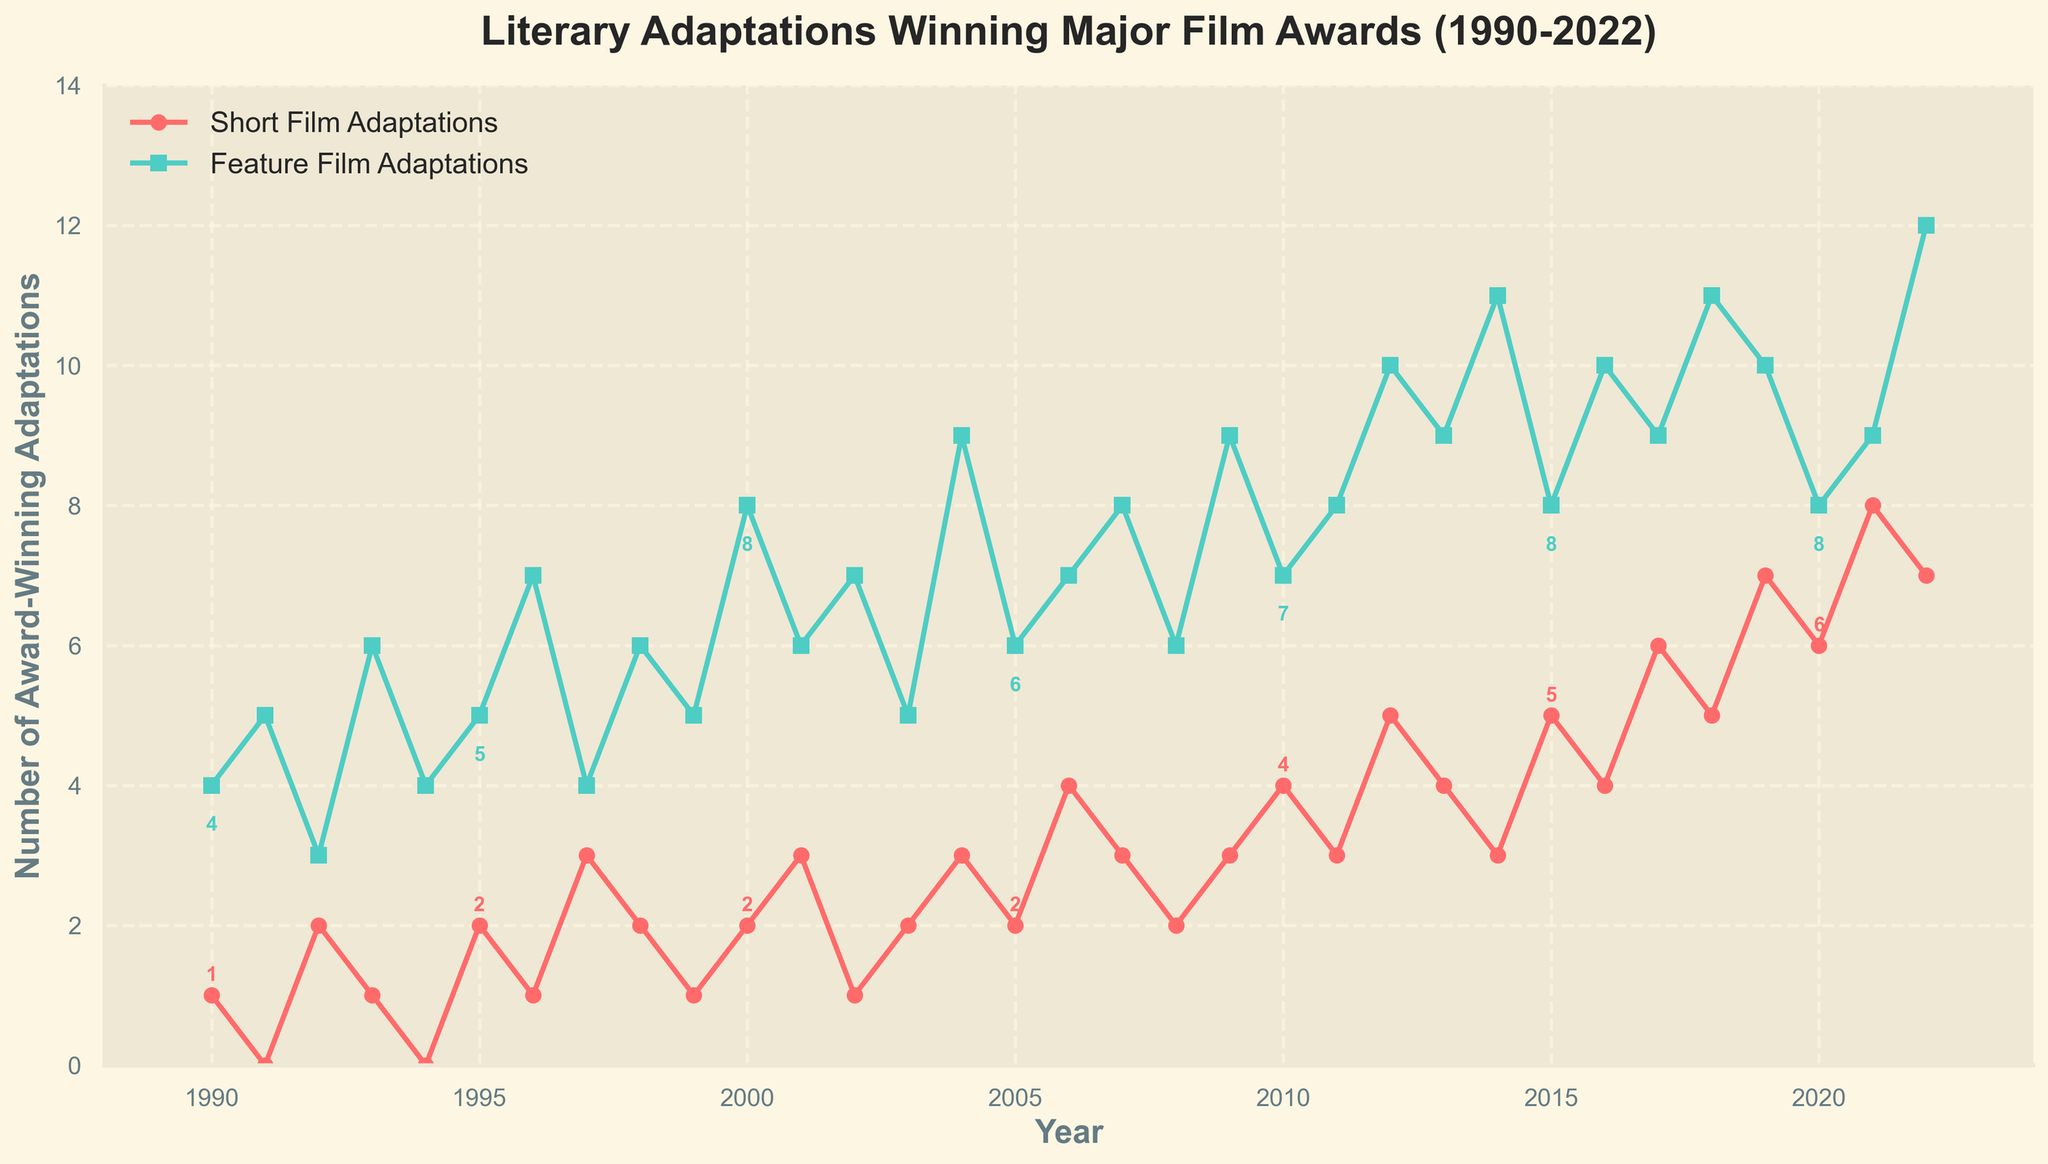What's the general trend in short film adaptations winning awards from 1990 to 2022? Observing the red line (representing short film adaptations), we notice an overall increase in the number of short film adaptations winning major film awards over the years, especially a noticeable rise from 2010 onwards.
Answer: An increasing trend In which year did feature film adaptations win the most awards, and how many did they win? The green line (representing feature film adaptations) peaks in 2022, and the annotation indicates it won 12 awards that year.
Answer: 2022, 12 awards In which year was there the highest number of short film adaptations winning awards, and how many did they win? The red line reaches its highest point in 2021, and the annotation shows 8 awards for that year.
Answer: 2021, 8 awards How many years did short film adaptations win more awards than feature film adaptations from 1990 to 2022? Comparing the two lines every year, the red line (short film adaptations) is above the green line (feature film adaptations) in only one year: 2019.
Answer: 1 year In what year(s) did short film adaptations win exactly 3 awards? The red line reaches 3 awards in 1997, 2004, 2007, 2009, 2011, and 2014. These years are also annotated with the value 3.
Answer: 1997, 2004, 2007, 2009, 2011, 2014 What is the average number of awards won by feature film adaptations from 1990 to 2000? Sum the feature film adaptation values from 1990 to 2000 and divide by the number of years (11). The values: 4, 5, 3, 6, 4, 5, 7, 4, 6, 5, 8. Sum = 57, and average = 57 / 11 ≈ 5.18.
Answer: Approximately 5.18 Which year showed the largest single-year increase in awards for short films? Examining year-over-year changes, the largest increase for short films is from 2021 (7) to 2022 (8), with a 1 award increase.
Answer: 2022 During which years did the lines for short film adaptations and feature film adaptations intersect? The red line (short films) and green line (feature films) intersect in 1992 and 2017, indicated by the lines crossing each other.
Answer: 1992, 2017 Compare the growth rate of awards won by short film adaptations from 2000 to 2010 with that from 2010 to 2020. From 2000 to 2010: Short films increased from 2 to 4, a difference of 2 in 10 years. From 2010 to 2020: Short films increased from 4 to 6, a difference of 2 in 10 years. Both periods have the same growth rate of 0.2 awards per year.
Answer: Same growth rate of 0.2 awards per year 